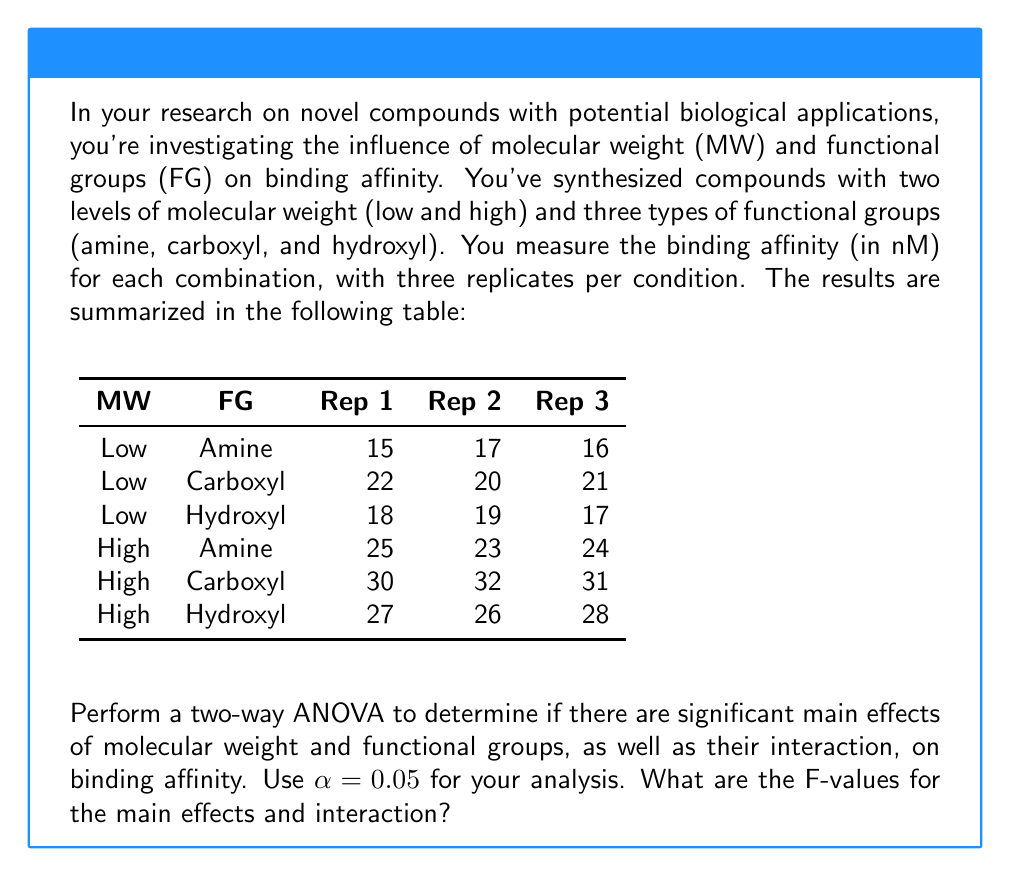Solve this math problem. To perform a two-way ANOVA, we need to follow these steps:

1. Calculate the sum of squares for each factor (SS$_{MW}$, SS$_{FG}$), their interaction (SS$_{MW×FG}$), and the error (SS$_{error}$).
2. Calculate the degrees of freedom for each factor (df$_{MW}$, df$_{FG}$), their interaction (df$_{MW×FG}$), and the error (df$_{error}$).
3. Calculate the mean squares for each factor (MS$_{MW}$, MS$_{FG}$), their interaction (MS$_{MW×FG}$), and the error (MS$_{error}$).
4. Calculate the F-values for each factor and their interaction.

Step 1: Calculate sum of squares

First, we need to calculate the total sum of squares (SS$_{total}$), which is the sum of squared deviations from the grand mean.

Grand mean = $\frac{(15+17+16+...+26+28)}{18} = 22.5$

SS$_{total}$ = $(15-22.5)^2 + (17-22.5)^2 + ... + (28-22.5)^2 = 702$

Next, we calculate the sum of squares for each factor and their interaction:

SS$_{MW}$ = $3 * 3 * ((18-22.5)^2 + (27-22.5)^2) = 486$
SS$_{FG}$ = $2 * 3 * ((20-22.5)^2 + (25.5-22.5)^2 + (22-22.5)^2) = 132$
SS$_{MW×FG}$ = $3 * ((16-18-20+22.5)^2 + (21-18-25.5+22.5)^2 + (18-18-22+22.5)^2) = 6$

SS$_{error}$ = SS$_{total}$ - SS$_{MW}$ - SS$_{FG}$ - SS$_{MW×FG}$ = $702 - 486 - 132 - 6 = 78$

Step 2: Calculate degrees of freedom

df$_{MW}$ = 1 (2 levels - 1)
df$_{FG}$ = 2 (3 levels - 1)
df$_{MW×FG}$ = 1 * 2 = 2
df$_{error}$ = 18 - (1 + 2 + 2) = 12
df$_{total}$ = 18 - 1 = 17

Step 3: Calculate mean squares

MS$_{MW}$ = SS$_{MW}$ / df$_{MW}$ = 486 / 1 = 486
MS$_{FG}$ = SS$_{FG}$ / df$_{FG}$ = 132 / 2 = 66
MS$_{MW×FG}$ = SS$_{MW×FG}$ / df$_{MW×FG}$ = 6 / 2 = 3
MS$_{error}$ = SS$_{error}$ / df$_{error}$ = 78 / 12 = 6.5

Step 4: Calculate F-values

F$_{MW}$ = MS$_{MW}$ / MS$_{error}$ = 486 / 6.5 = 74.77
F$_{FG}$ = MS$_{FG}$ / MS$_{error}$ = 66 / 6.5 = 10.15
F$_{MW×FG}$ = MS$_{MW×FG}$ / MS$_{error}$ = 3 / 6.5 = 0.46
Answer: F$_{MW}$ = 74.77, F$_{FG}$ = 10.15, F$_{MW×FG}$ = 0.46 